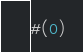Convert code to text. <code><loc_0><loc_0><loc_500><loc_500><_Scheme_>#(0)</code> 